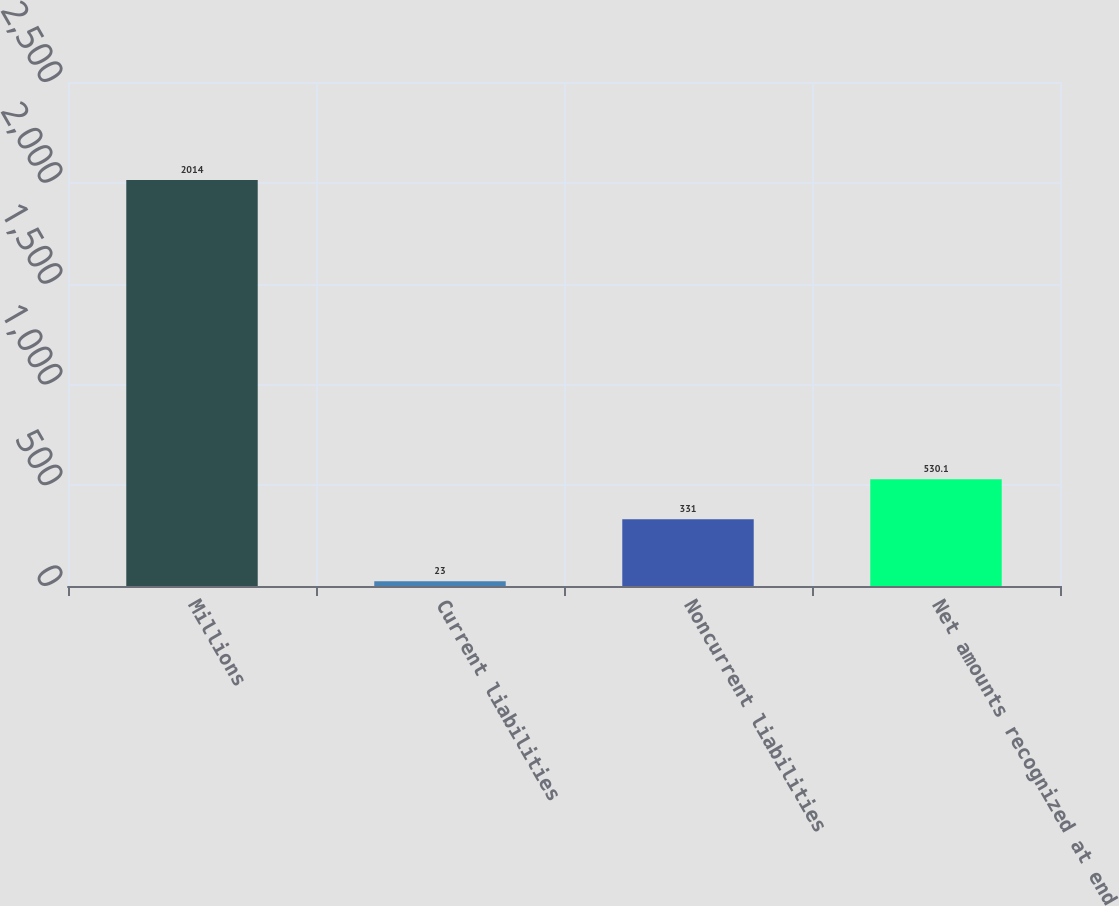Convert chart to OTSL. <chart><loc_0><loc_0><loc_500><loc_500><bar_chart><fcel>Millions<fcel>Current liabilities<fcel>Noncurrent liabilities<fcel>Net amounts recognized at end<nl><fcel>2014<fcel>23<fcel>331<fcel>530.1<nl></chart> 